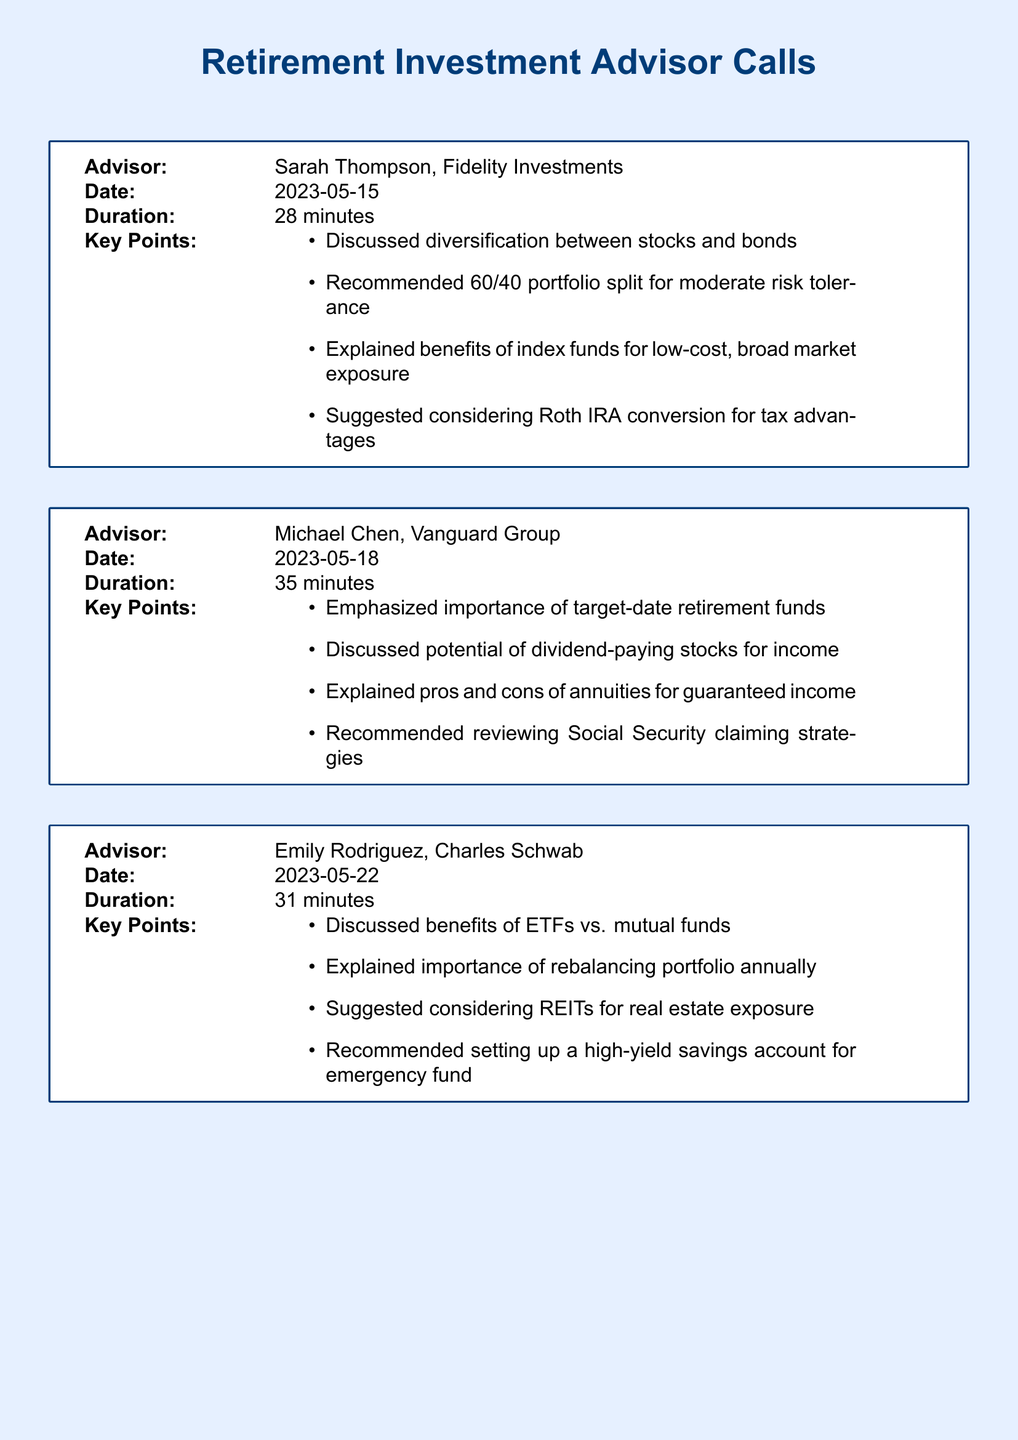What is the name of the first advisor? The first advisor mentioned in the document is Sarah Thompson from Fidelity Investments.
Answer: Sarah Thompson What date did Michael Chen provide his advice? Michael Chen's conversation took place on May 18, 2023.
Answer: 2023-05-18 How many minutes did the call with David Wilson last? The duration of David Wilson's call is recorded as 26 minutes.
Answer: 26 minutes What investment strategy did Emily Rodriguez suggest for real estate exposure? Emily Rodriguez recommended considering REITs for real estate exposure.
Answer: REITs What percentage portfolio split did Sarah Thompson recommend for moderate risk tolerance? Sarah Thompson recommended a 60/40 portfolio split for moderate risk tolerance.
Answer: 60/40 Which advisor emphasized the importance of target-date retirement funds? Michael Chen emphasized the importance of target-date retirement funds during his call.
Answer: Michael Chen What is one benefit of a Roth IRA conversion discussed by Sarah Thompson? One benefit discussed is tax advantages of a Roth IRA conversion.
Answer: Tax advantages How many advisors discussed strategies for minimizing taxes in retirement? Only one advisor, David Wilson, discussed strategies for minimizing taxes in retirement.
Answer: One What type of investment did Emily Rodriguez compare ETFs with? Emily Rodriguez discussed the benefits of ETFs compared to mutual funds.
Answer: Mutual funds 